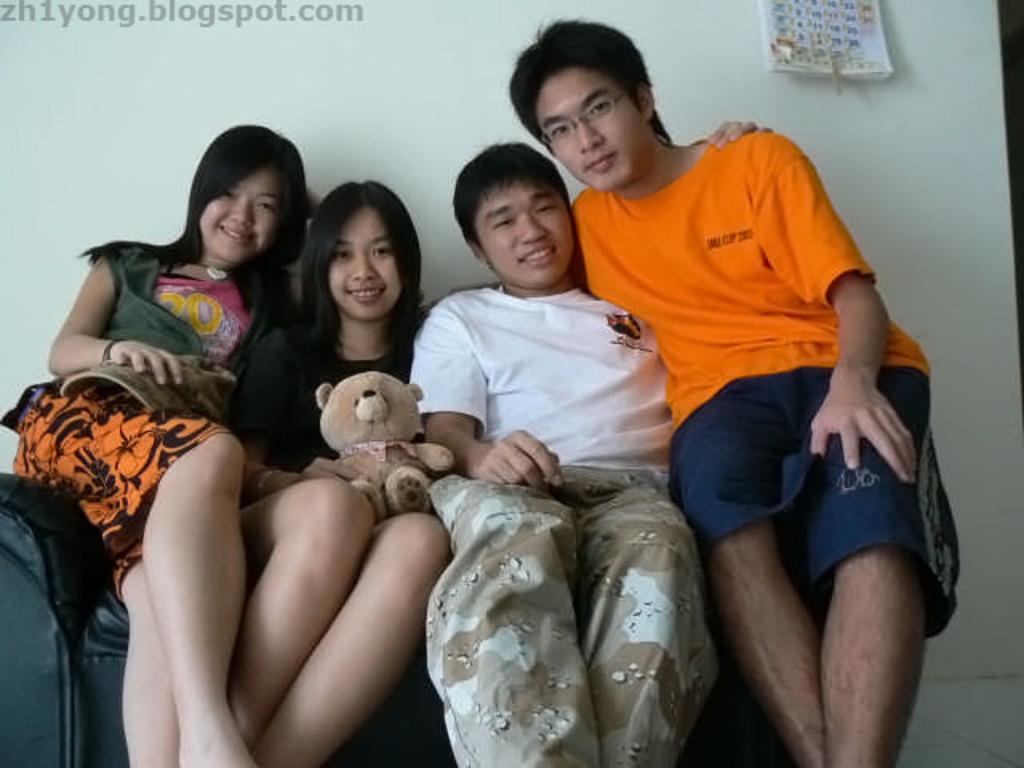Could you give a brief overview of what you see in this image? In the center of the image we can see four persons are sitting on the couch and they are smiling. Among them, we can see one person is wearing glasses and two persons are holding some objects. In the background, there is a wall and a calendar. At the top left side of the image, we can see some text. 